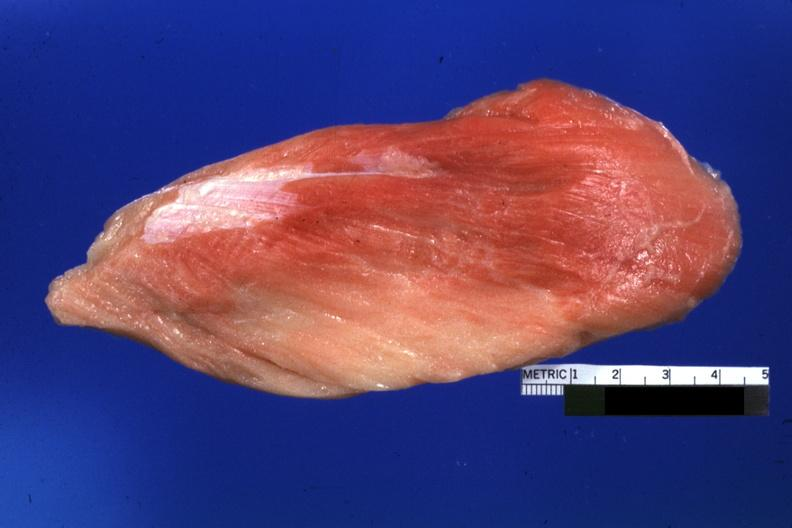what is present?
Answer the question using a single word or phrase. Soft tissue 